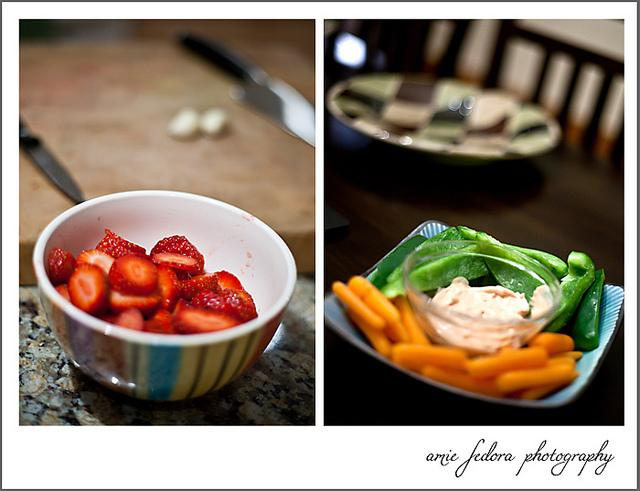What is in the bowl on the left? strawberries 